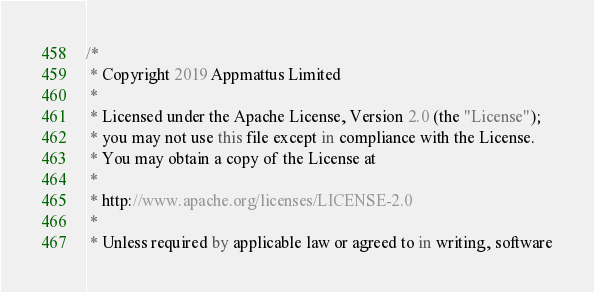<code> <loc_0><loc_0><loc_500><loc_500><_Kotlin_>/*
 * Copyright 2019 Appmattus Limited
 *
 * Licensed under the Apache License, Version 2.0 (the "License");
 * you may not use this file except in compliance with the License.
 * You may obtain a copy of the License at
 *
 * http://www.apache.org/licenses/LICENSE-2.0
 *
 * Unless required by applicable law or agreed to in writing, software</code> 